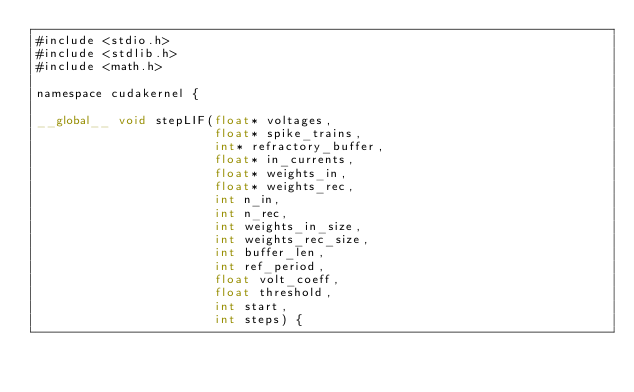<code> <loc_0><loc_0><loc_500><loc_500><_Cuda_>#include <stdio.h>
#include <stdlib.h>
#include <math.h>

namespace cudakernel {

__global__ void stepLIF(float* voltages,
                        float* spike_trains,
                        int* refractory_buffer,
                        float* in_currents,
                        float* weights_in,
                        float* weights_rec,
                        int n_in,
                        int n_rec,
                        int weights_in_size,
                        int weights_rec_size,
                        int buffer_len,
                        int ref_period,
                        float volt_coeff,
                        float threshold,
                        int start,
                        int steps) {
</code> 